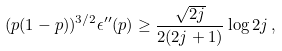<formula> <loc_0><loc_0><loc_500><loc_500>( p ( 1 - p ) ) ^ { 3 / 2 } \epsilon ^ { \prime \prime } ( p ) \geq \frac { \sqrt { 2 j } } { 2 ( 2 j + 1 ) } \log { 2 j } \, ,</formula> 